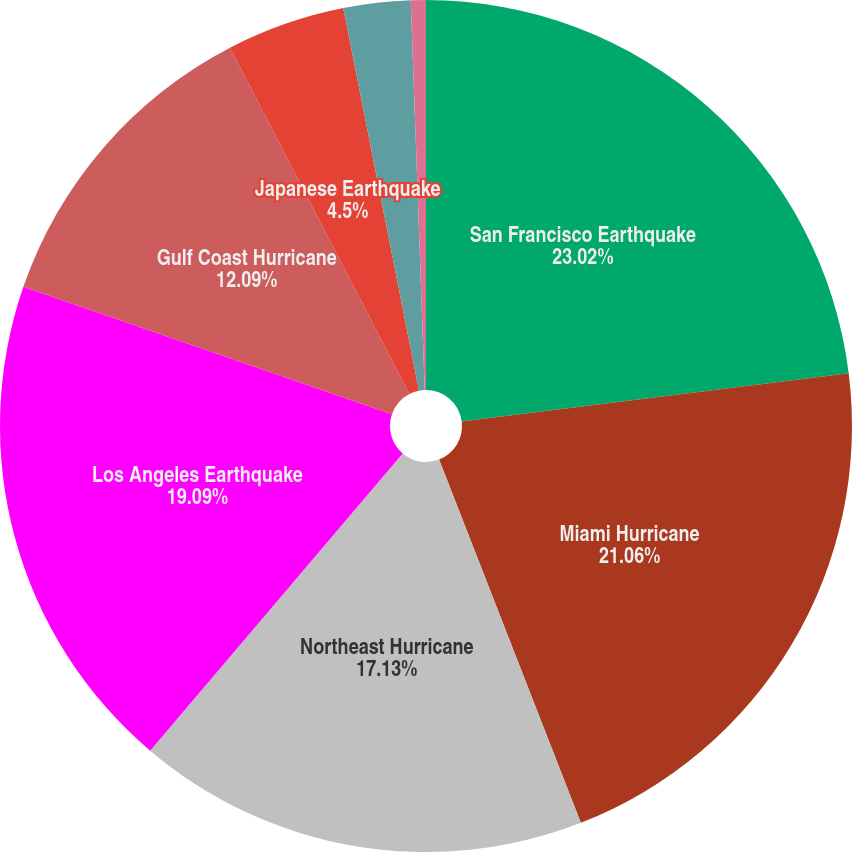<chart> <loc_0><loc_0><loc_500><loc_500><pie_chart><fcel>San Francisco Earthquake<fcel>Miami Hurricane<fcel>Northeast Hurricane<fcel>Los Angeles Earthquake<fcel>Gulf Coast Hurricane<fcel>Japanese Earthquake<fcel>European Windstorm<fcel>Japanese Typhoon<nl><fcel>23.02%<fcel>21.06%<fcel>17.13%<fcel>19.09%<fcel>12.09%<fcel>4.5%<fcel>2.54%<fcel>0.57%<nl></chart> 